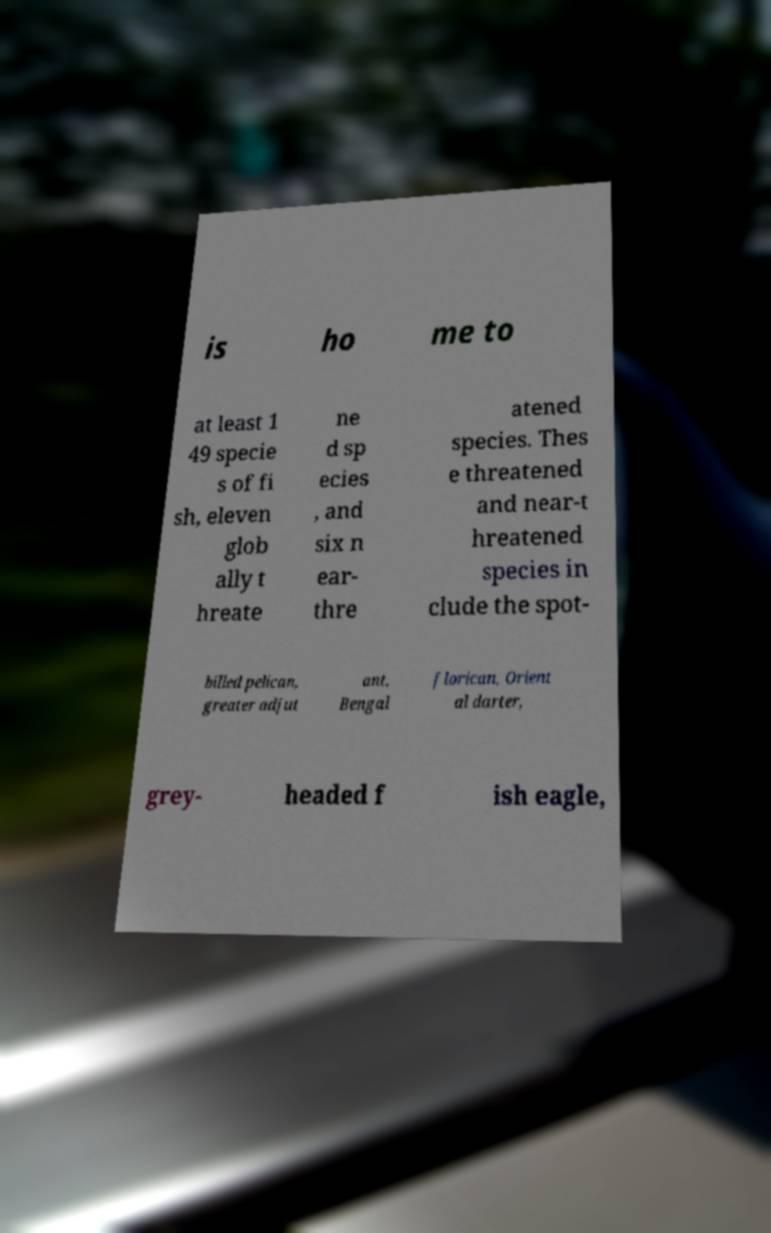There's text embedded in this image that I need extracted. Can you transcribe it verbatim? is ho me to at least 1 49 specie s of fi sh, eleven glob ally t hreate ne d sp ecies , and six n ear- thre atened species. Thes e threatened and near-t hreatened species in clude the spot- billed pelican, greater adjut ant, Bengal florican, Orient al darter, grey- headed f ish eagle, 